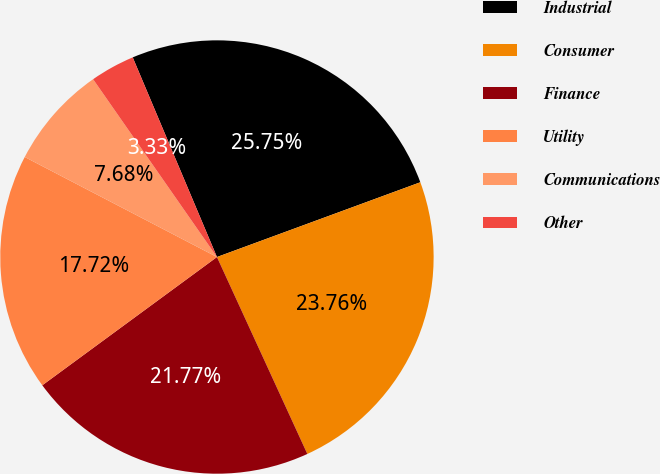Convert chart. <chart><loc_0><loc_0><loc_500><loc_500><pie_chart><fcel>Industrial<fcel>Consumer<fcel>Finance<fcel>Utility<fcel>Communications<fcel>Other<nl><fcel>25.75%<fcel>23.76%<fcel>21.77%<fcel>17.72%<fcel>7.68%<fcel>3.33%<nl></chart> 